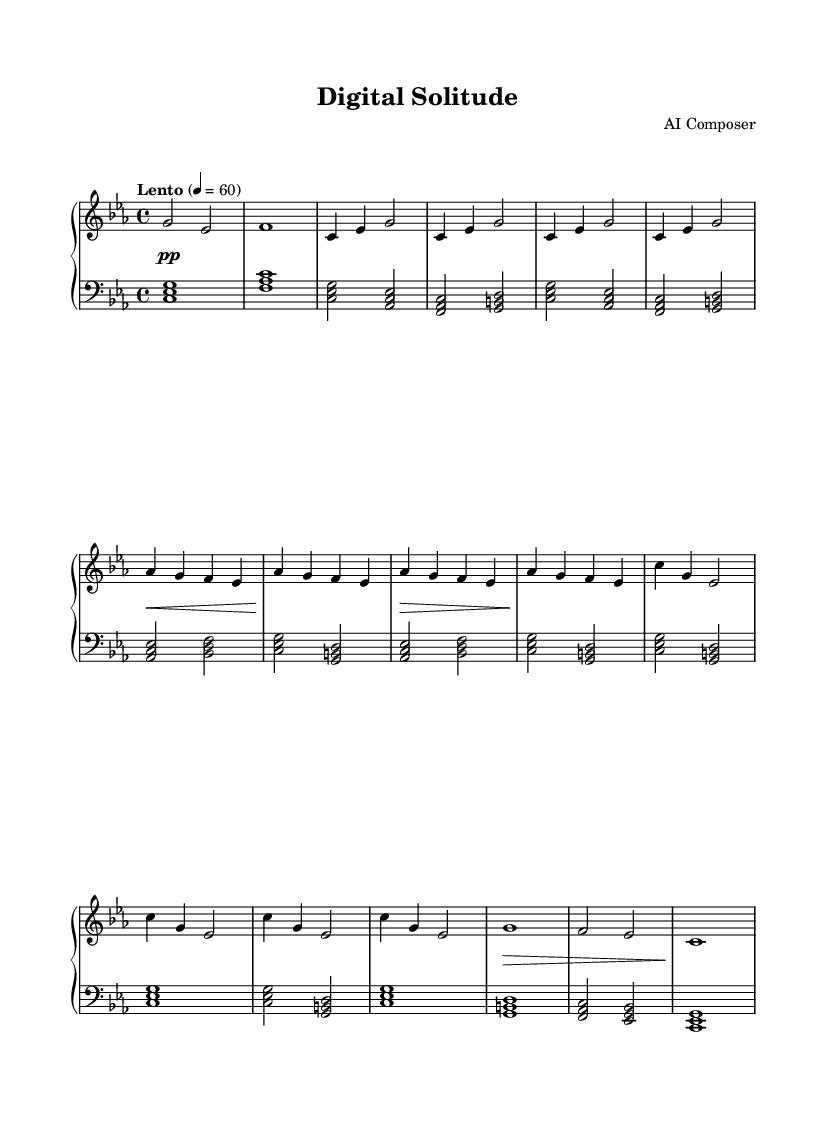What is the key signature of this music? The key signature is C minor, which has three flats: B flat, E flat, and A flat. This can be identified by looking at the key signature at the beginning of the staff.
Answer: C minor What is the time signature of this piece? The time signature is 4/4, indicating that there are four beats in each measure and that a quarter note receives one beat. This is seen at the beginning of the score next to the key signature.
Answer: 4/4 What is the tempo marking for the piece? The tempo marking is "Lento," which indicates a slow pace. This is specified in the tempo notation found in the score.
Answer: Lento How many measures are in Theme A? Theme A consists of 4 measures, identified by counting the measures in the section where Theme A is stated, which includes the repetitions and the structure of the music.
Answer: 4 Which dynamic marking appears first in the dynamics? The first dynamic marking is "piano," abbreviated as "pp," indicating a soft volume. This is located at the beginning of the dynamics section.
Answer: pp What is the final note of the Coda section? The final note of the Coda section is C, which can be determined by looking at the last measure of the Coda where the note C is placed in the bass clef.
Answer: C 